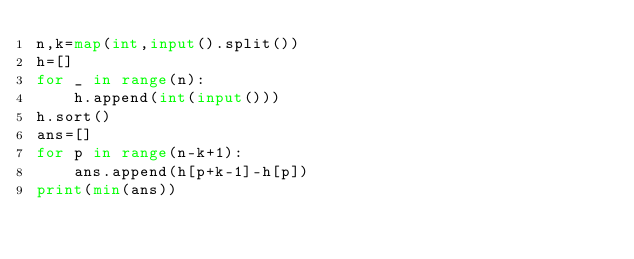Convert code to text. <code><loc_0><loc_0><loc_500><loc_500><_Python_>n,k=map(int,input().split())
h=[]
for _ in range(n):
    h.append(int(input()))
h.sort()
ans=[]
for p in range(n-k+1):
    ans.append(h[p+k-1]-h[p])
print(min(ans))</code> 